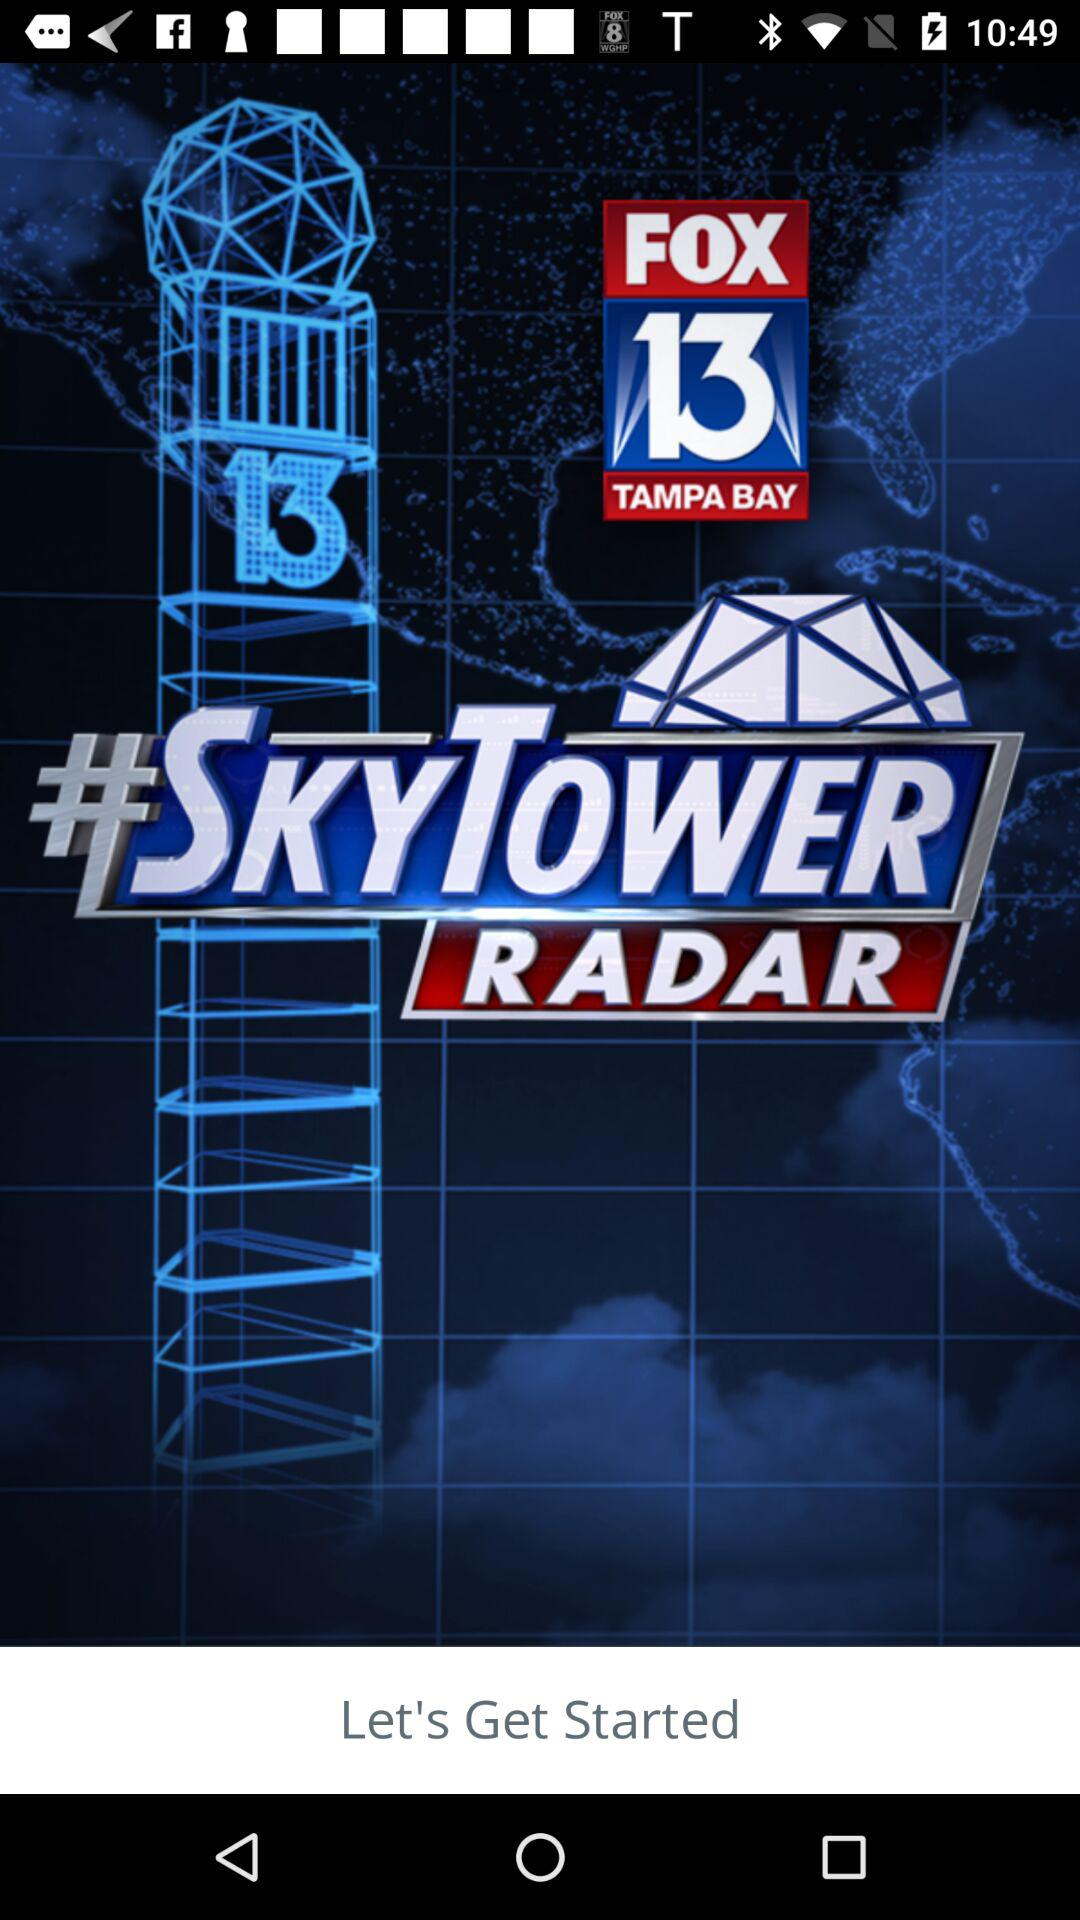What is the app name? The app name is "FOX 13 TAMPA BAY". 